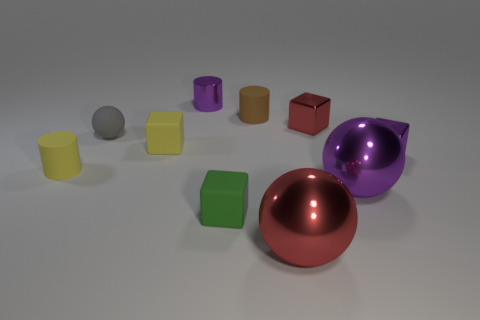Subtract all metallic balls. How many balls are left? 1 Subtract all gray balls. How many balls are left? 2 Subtract 1 cylinders. How many cylinders are left? 2 Subtract all green cubes. Subtract all yellow cylinders. How many cubes are left? 3 Subtract all tiny spheres. Subtract all green blocks. How many objects are left? 8 Add 4 red shiny things. How many red shiny things are left? 6 Add 9 tiny brown metallic cylinders. How many tiny brown metallic cylinders exist? 9 Subtract 0 blue cubes. How many objects are left? 10 Subtract all spheres. How many objects are left? 7 